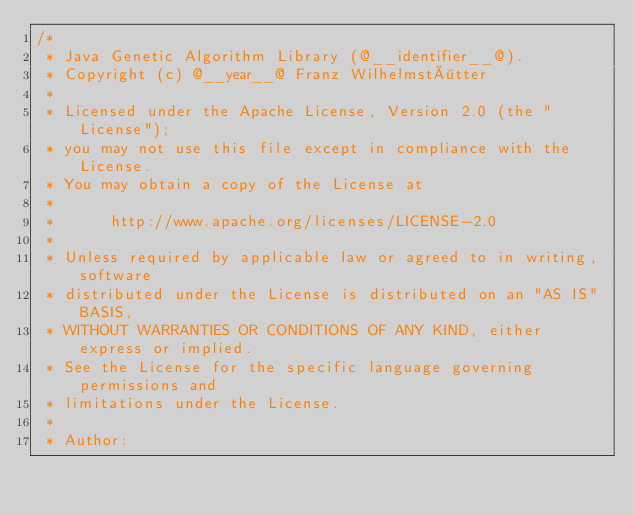<code> <loc_0><loc_0><loc_500><loc_500><_Java_>/*
 * Java Genetic Algorithm Library (@__identifier__@).
 * Copyright (c) @__year__@ Franz Wilhelmstötter
 *
 * Licensed under the Apache License, Version 2.0 (the "License");
 * you may not use this file except in compliance with the License.
 * You may obtain a copy of the License at
 *
 *      http://www.apache.org/licenses/LICENSE-2.0
 *
 * Unless required by applicable law or agreed to in writing, software
 * distributed under the License is distributed on an "AS IS" BASIS,
 * WITHOUT WARRANTIES OR CONDITIONS OF ANY KIND, either express or implied.
 * See the License for the specific language governing permissions and
 * limitations under the License.
 *
 * Author:</code> 